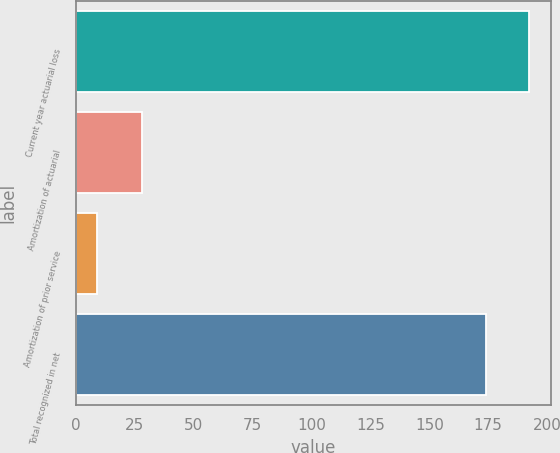<chart> <loc_0><loc_0><loc_500><loc_500><bar_chart><fcel>Current year actuarial loss<fcel>Amortization of actuarial<fcel>Amortization of prior service<fcel>Total recognized in net<nl><fcel>192.2<fcel>28<fcel>9<fcel>174<nl></chart> 